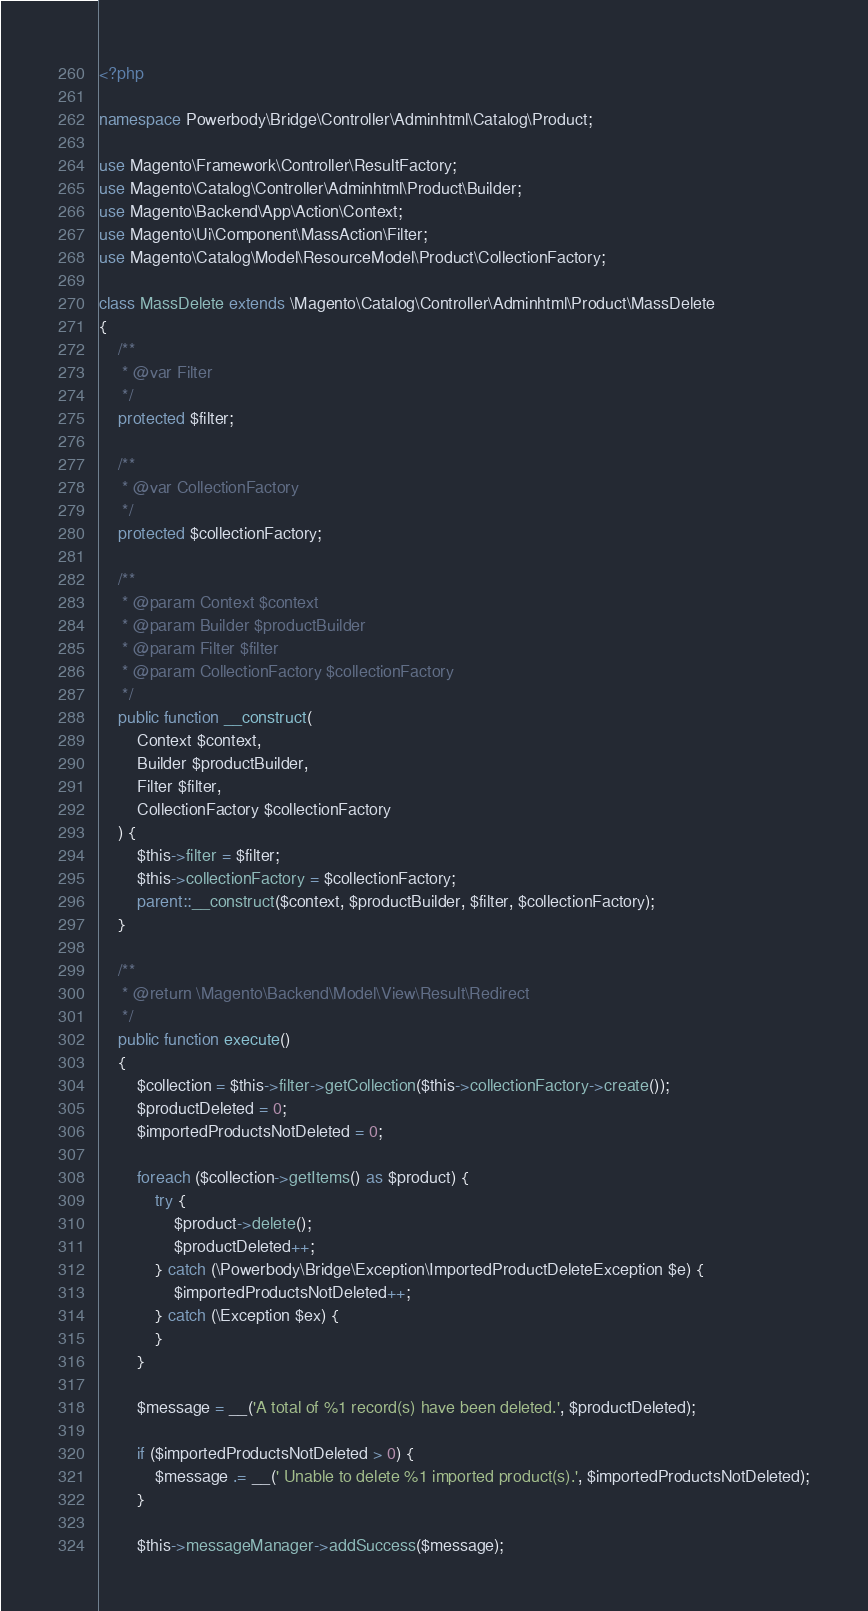Convert code to text. <code><loc_0><loc_0><loc_500><loc_500><_PHP_><?php

namespace Powerbody\Bridge\Controller\Adminhtml\Catalog\Product;

use Magento\Framework\Controller\ResultFactory;
use Magento\Catalog\Controller\Adminhtml\Product\Builder;
use Magento\Backend\App\Action\Context;
use Magento\Ui\Component\MassAction\Filter;
use Magento\Catalog\Model\ResourceModel\Product\CollectionFactory;

class MassDelete extends \Magento\Catalog\Controller\Adminhtml\Product\MassDelete
{
    /**
     * @var Filter
     */
    protected $filter;

    /**
     * @var CollectionFactory
     */
    protected $collectionFactory;

    /**
     * @param Context $context
     * @param Builder $productBuilder
     * @param Filter $filter
     * @param CollectionFactory $collectionFactory
     */
    public function __construct(
        Context $context,
        Builder $productBuilder,
        Filter $filter,
        CollectionFactory $collectionFactory
    ) {
        $this->filter = $filter;
        $this->collectionFactory = $collectionFactory;
        parent::__construct($context, $productBuilder, $filter, $collectionFactory);
    }

    /**
     * @return \Magento\Backend\Model\View\Result\Redirect
     */
    public function execute()
    {
        $collection = $this->filter->getCollection($this->collectionFactory->create());
        $productDeleted = 0;
        $importedProductsNotDeleted = 0;

        foreach ($collection->getItems() as $product) {
            try {
                $product->delete();
                $productDeleted++;
            } catch (\Powerbody\Bridge\Exception\ImportedProductDeleteException $e) {
                $importedProductsNotDeleted++;
            } catch (\Exception $ex) {
            }
        }
        
        $message = __('A total of %1 record(s) have been deleted.', $productDeleted);

        if ($importedProductsNotDeleted > 0) {
            $message .= __(' Unable to delete %1 imported product(s).', $importedProductsNotDeleted);
        }

        $this->messageManager->addSuccess($message);
</code> 